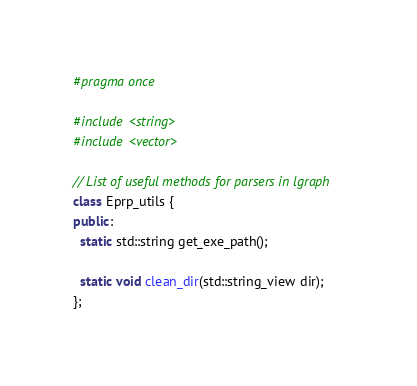<code> <loc_0><loc_0><loc_500><loc_500><_C++_>#pragma once

#include <string>
#include <vector>

// List of useful methods for parsers in lgraph
class Eprp_utils {
public:
  static std::string get_exe_path();

  static void clean_dir(std::string_view dir);
};
</code> 